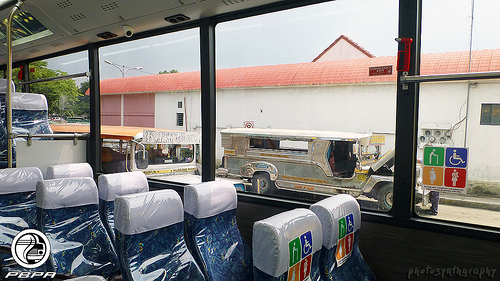<image>
Is there a seat next to the vehicle? No. The seat is not positioned next to the vehicle. They are located in different areas of the scene. Is the car behind the buliding? No. The car is not behind the buliding. From this viewpoint, the car appears to be positioned elsewhere in the scene. Is there a wheel behind the wall? No. The wheel is not behind the wall. From this viewpoint, the wheel appears to be positioned elsewhere in the scene. Is the wheel on the bus? No. The wheel is not positioned on the bus. They may be near each other, but the wheel is not supported by or resting on top of the bus. 